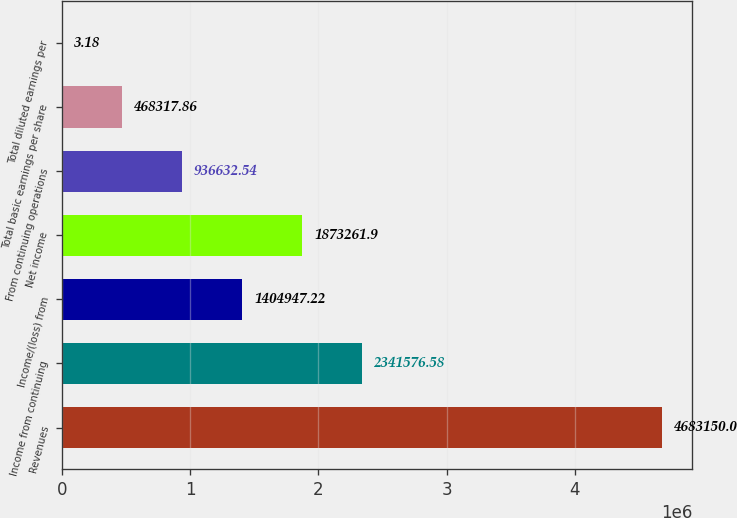<chart> <loc_0><loc_0><loc_500><loc_500><bar_chart><fcel>Revenues<fcel>Income from continuing<fcel>Income/(loss) from<fcel>Net income<fcel>From continuing operations<fcel>Total basic earnings per share<fcel>Total diluted earnings per<nl><fcel>4.68315e+06<fcel>2.34158e+06<fcel>1.40495e+06<fcel>1.87326e+06<fcel>936633<fcel>468318<fcel>3.18<nl></chart> 